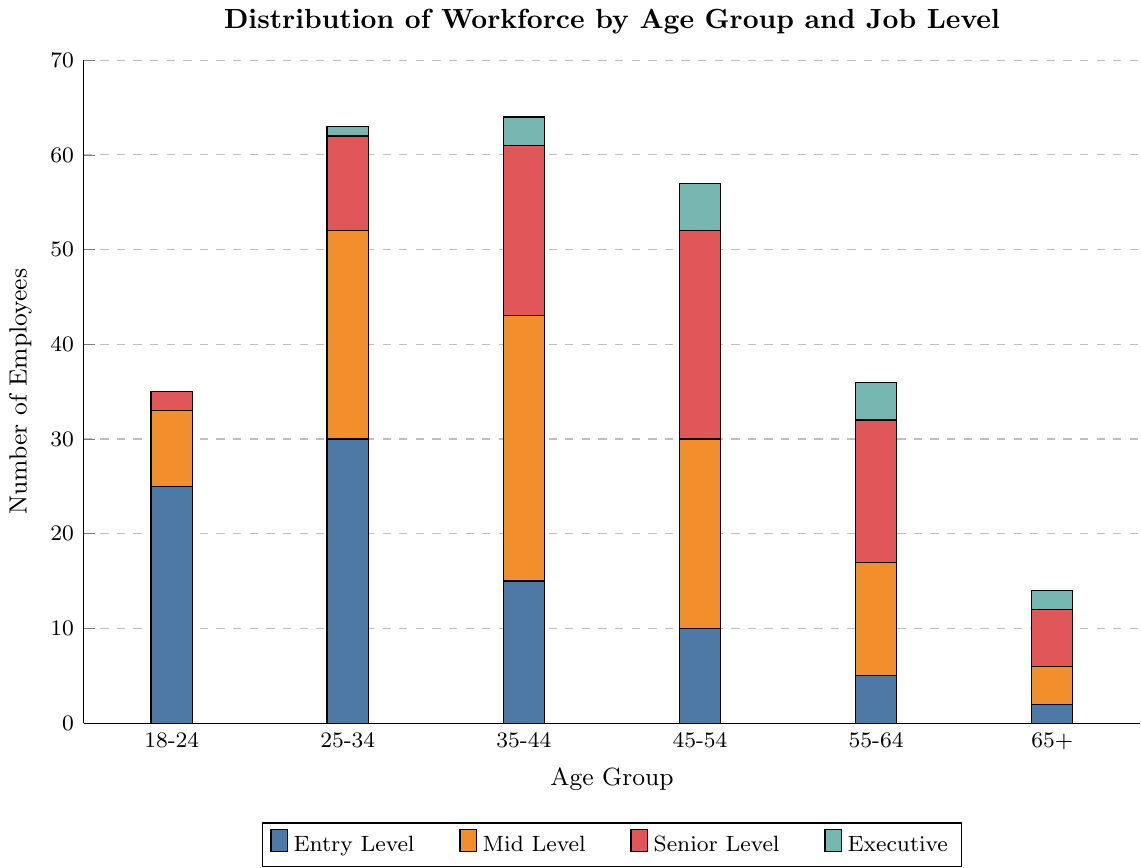Which age group has the highest number of senior-level employees? The senior level employees are represented by the third color (red). By visual inspection, the age group 45-54 bars are the tallest in this category.
Answer: 45-54 How many total entry-level employees are there across all age groups? The entry-level employees are represented by the first color (blue). Summing the counts: 25 (18-24) + 30 (25-34) + 15 (35-44) + 10 (45-54) + 5 (55-64) + 2 (65+) = 87
Answer: 87 Which job level has the most employees in the 25-34 age group? For 25-34, the heights of the bar segments indicate the counts: 30 (Entry Level), 22 (Mid Level), 10 (Senior Level), 1 (Executive). The highest value is Entry Level (30).
Answer: Entry Level Compare the number of mid-level employees in the 35-44 age group to those in the 45-54 age group. Which is greater? For mid-level employees, compare 28 (35-44) to 20 (45-54). Thus, 28 > 20.
Answer: 35-44 What is the total number of employees in the 55-64 age group? Adding up all job levels for 55-64: 5 (Entry Level) + 12 (Mid Level) + 15 (Senior Level) + 4 (Executive) = 36.
Answer: 36 How many more executive-level employees are there in the 45-54 age group compared to the 25-34 age group? Comparing the height of the executive bar segments: 5 (45-54) - 1 (25-34) = 4 more executives in the 45-54 age group.
Answer: 4 Which age group has the least number of total employees? Add up all job levels for each age group and compare: 18-24 = 35, 25-34 = 63, 35-44 = 64, 45-54 = 57, 55-64 = 36, 65+ = 14. The age group 65+ has the least number of employees.
Answer: 65+ What is the average number of mid-level employees per age group? Sum of mid-level employees: 8 (18-24) + 22 (25-34) + 28 (35-44) + 20 (45-54) + 12 (55-64) + 4 (65+) = 94. Average = 94 / 6 ≈ 15.67.
Answer: 15.67 In which age group is the number of entry-level employees closest to the number of senior-level employees? Compare the values in each age group to find the closest match: For 18-24 (25 vs 2), 25-34 (30 vs 10), 35-44 (15 vs 18), 45-54 (10 vs 22), 55-64 (5 vs 15), 65+ (2 vs 6), the closest match is in 35-44 (15 vs 18).
Answer: 35-44 